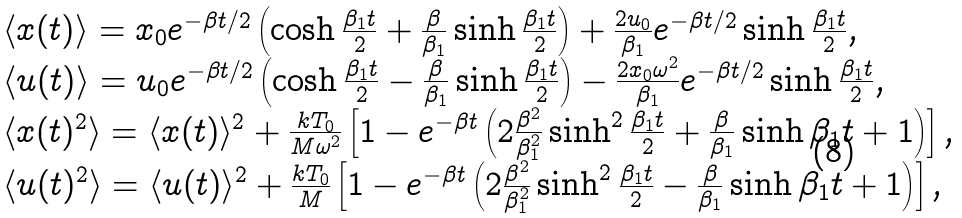Convert formula to latex. <formula><loc_0><loc_0><loc_500><loc_500>\begin{array} { l } \langle x ( t ) \rangle = x _ { 0 } e ^ { - \beta t / 2 } \left ( \cosh \frac { \beta _ { 1 } t } { 2 } + \frac { \beta } { \beta _ { 1 } } \sinh \frac { \beta _ { 1 } t } { 2 } \right ) + \frac { 2 u _ { 0 } } { \beta _ { 1 } } e ^ { - \beta t / 2 } \sinh \frac { \beta _ { 1 } t } { 2 } \text {,} \\ \langle u ( t ) \rangle = u _ { 0 } e ^ { - \beta t / 2 } \left ( \cosh \frac { \beta _ { 1 } t } { 2 } - \frac { \beta } { \beta _ { 1 } } \sinh \frac { \beta _ { 1 } t } { 2 } \right ) - \frac { 2 x _ { 0 } \omega ^ { 2 } } { \beta _ { 1 } } e ^ { - \beta t / 2 } \sinh \frac { \beta _ { 1 } t } { 2 } \text {,} \\ \langle x ( t ) ^ { 2 } \rangle = \langle x ( t ) \rangle ^ { 2 } + \frac { k T _ { 0 } } { M \omega ^ { 2 } } \left [ 1 - e ^ { - \beta t } \left ( 2 \frac { \beta ^ { 2 } } { \beta _ { 1 } ^ { 2 } } \sinh ^ { 2 } \frac { \beta _ { 1 } t } { 2 } + \frac { \beta } { \beta _ { 1 } } \sinh \beta _ { 1 } t + 1 \right ) \right ] \text {,} \\ \langle u ( t ) ^ { 2 } \rangle = \langle u ( t ) \rangle ^ { 2 } + \frac { k T _ { 0 } } { M } \left [ 1 - e ^ { - \beta t } \left ( 2 \frac { \beta ^ { 2 } } { \beta _ { 1 } ^ { 2 } } \sinh ^ { 2 } \frac { \beta _ { 1 } t } { 2 } - \frac { \beta } { \beta _ { 1 } } \sinh \beta _ { 1 } t + 1 \right ) \right ] \text {,} \end{array}</formula> 